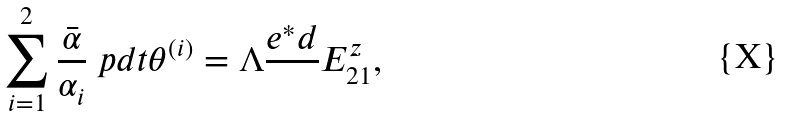Convert formula to latex. <formula><loc_0><loc_0><loc_500><loc_500>\sum _ { i = 1 } ^ { 2 } \frac { \bar { \alpha } } { \alpha _ { i } } \ p d t \theta ^ { ( i ) } = \Lambda \frac { e ^ { \ast } d } { } E _ { 2 1 } ^ { z } ,</formula> 